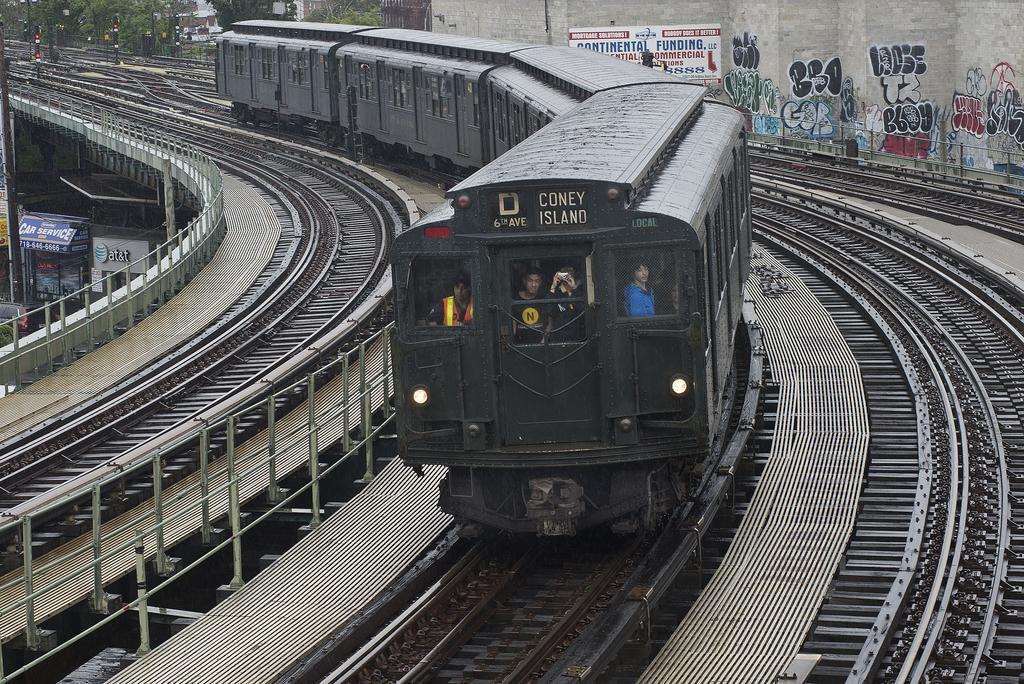<image>
Relay a brief, clear account of the picture shown. a coney island train that is on a track 